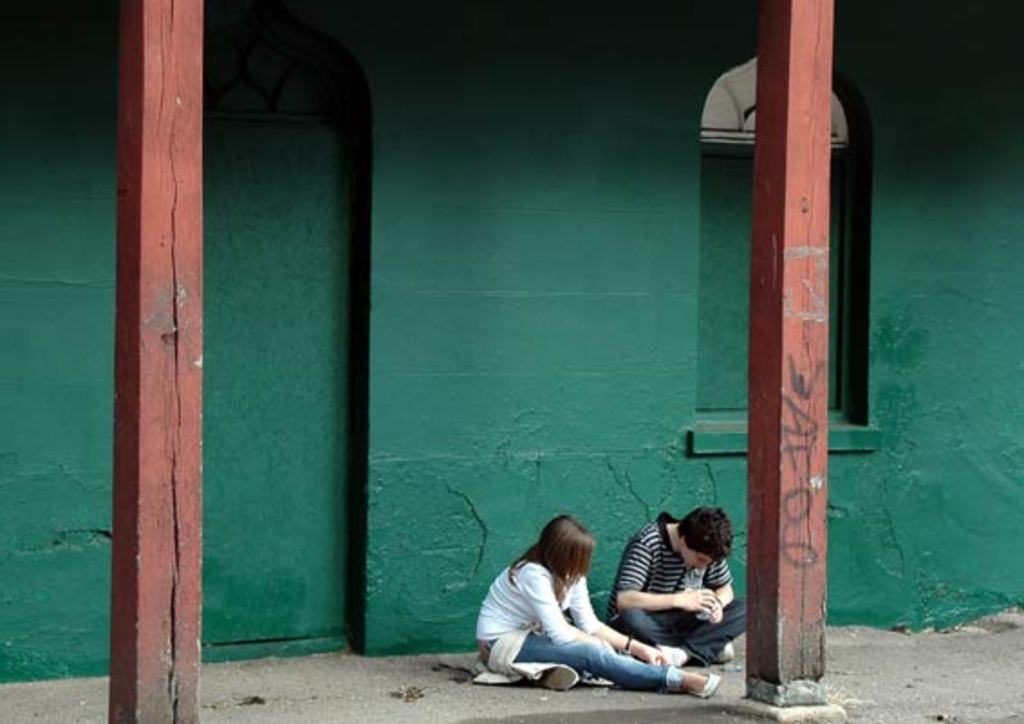How many people are sitting in the image? There are two people sitting near a green wall in the image. What can be seen in the background of the image? There are two pillars in the image. What is one of the men doing in the image? One man is holding an object. Can you describe the text on the pillar in the image? There is some text on the pillar on the right side of the image. What advice is the person on the left giving to the person on the right in the image? There is no indication in the image that the two people are giving or receiving advice. 